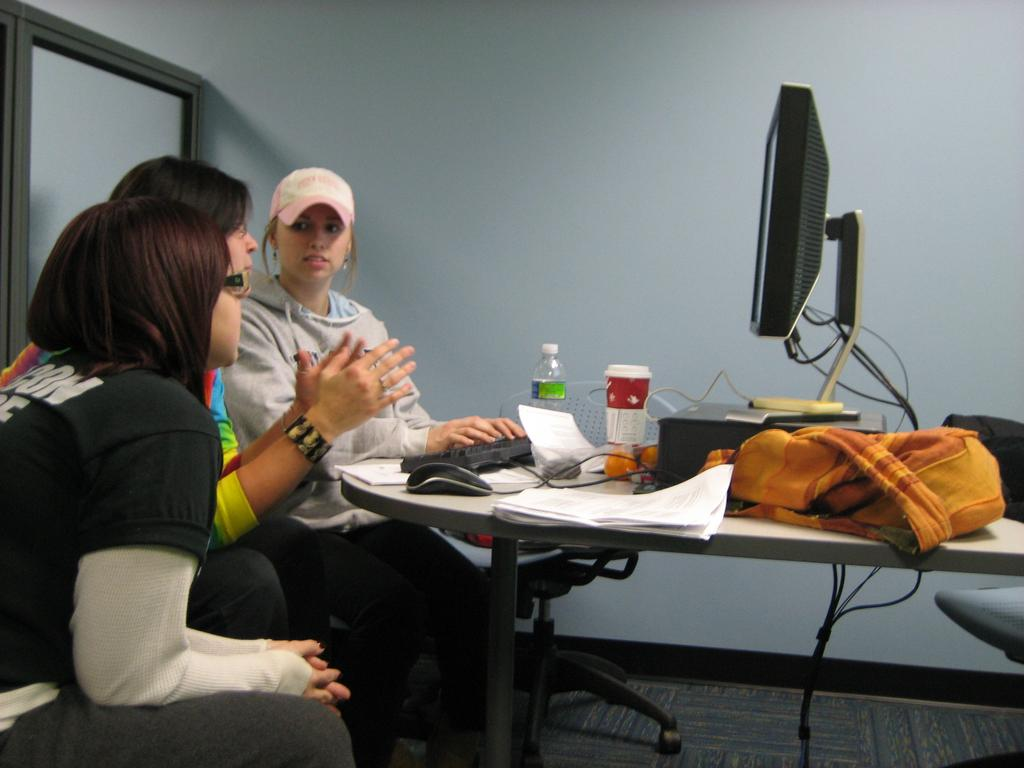What are the people in the image doing? The people are sitting on chairs. Where are the chairs located in relation to the table? The chairs are near a table. What electronic device is on the table? There is a monitor on the table. What other objects can be seen on the table? There is a bottle, a glass, a paper, and a bag on the table. How many cents are scattered on the table in the image? There are no cents visible on the table in the image. What type of pen is used to write on the paper in the image? There is no pen visible on the paper in the image. 